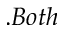<formula> <loc_0><loc_0><loc_500><loc_500>. B o t h</formula> 